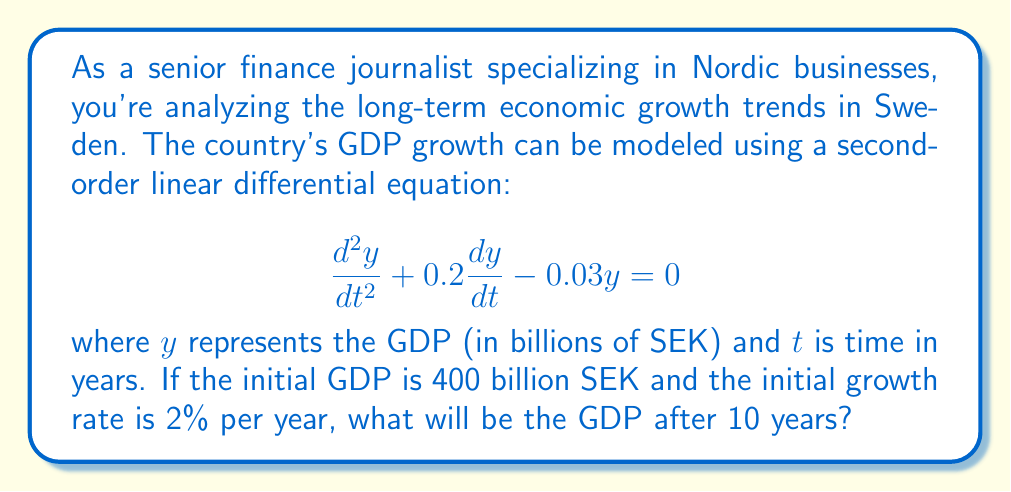Teach me how to tackle this problem. To solve this problem, we need to follow these steps:

1) The general solution for this second-order linear differential equation is:

   $$y = C_1e^{r_1t} + C_2e^{r_2t}$$

   where $r_1$ and $r_2$ are the roots of the characteristic equation.

2) The characteristic equation is:
   
   $$r^2 + 0.2r - 0.03 = 0$$

3) Solving this quadratic equation:
   
   $$r = \frac{-0.2 \pm \sqrt{0.2^2 + 4(0.03)}}{2} = \frac{-0.2 \pm \sqrt{0.16}}{2}$$
   
   $$r_1 = \frac{-0.2 + 0.4}{2} = 0.1$$
   $$r_2 = \frac{-0.2 - 0.4}{2} = -0.3$$

4) Therefore, the general solution is:

   $$y = C_1e^{0.1t} + C_2e^{-0.3t}$$

5) We need to find $C_1$ and $C_2$ using the initial conditions:
   
   At $t=0$, $y = 400$ and $\frac{dy}{dt} = 0.02 * 400 = 8$

6) From the first condition:
   
   $$400 = C_1 + C_2$$

7) From the second condition:
   
   $$8 = 0.1C_1 - 0.3C_2$$

8) Solving these equations:
   
   $$C_1 = 500, C_2 = -100$$

9) The particular solution is:

   $$y = 500e^{0.1t} - 100e^{-0.3t}$$

10) To find the GDP after 10 years, we substitute $t=10$:

    $$y = 500e^{1} - 100e^{-3} = 500e - 100e^{-3}$$

11) Calculate the final value:
    
    $$y \approx 1359.45 - 0.05 \approx 1359.40$$
Answer: The GDP of Sweden after 10 years will be approximately 1359.40 billion SEK. 